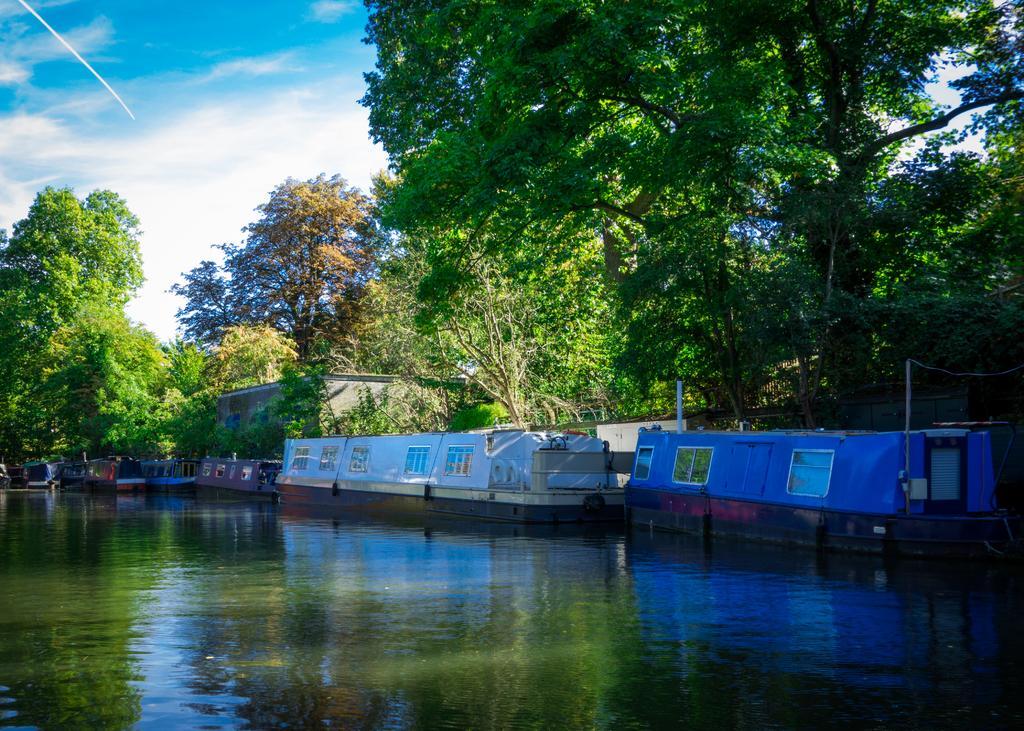Can you describe this image briefly? In this picture we can observe boats floating on the water. There are some trees. In the background there is a sky with clouds. 